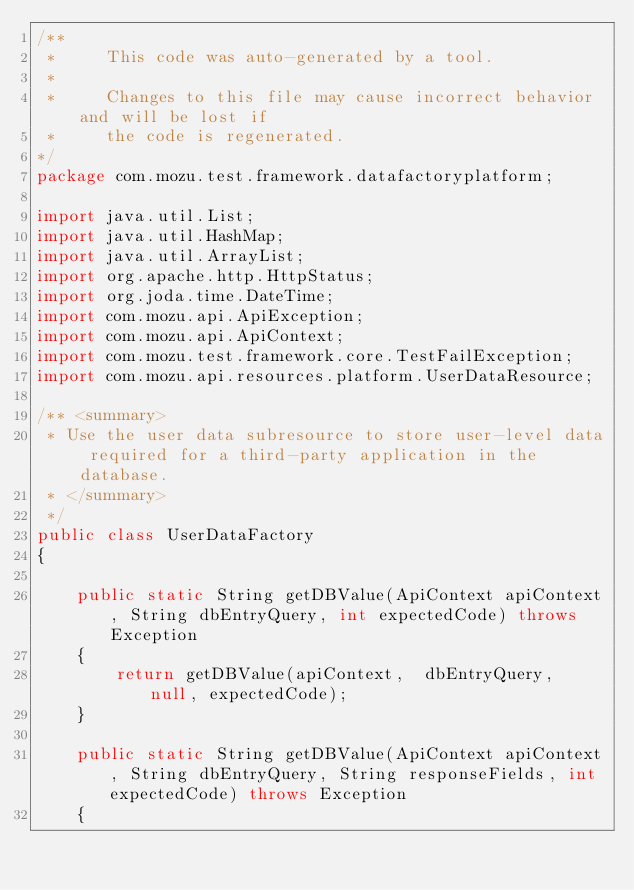<code> <loc_0><loc_0><loc_500><loc_500><_Java_>/**
 *     This code was auto-generated by a tool.     
 *
 *     Changes to this file may cause incorrect behavior and will be lost if
 *     the code is regenerated.
*/
package com.mozu.test.framework.datafactoryplatform;

import java.util.List;
import java.util.HashMap;
import java.util.ArrayList;
import org.apache.http.HttpStatus;
import org.joda.time.DateTime;
import com.mozu.api.ApiException;
import com.mozu.api.ApiContext;
import com.mozu.test.framework.core.TestFailException;
import com.mozu.api.resources.platform.UserDataResource;

/** <summary>
 * Use the user data subresource to store user-level data required for a third-party application in the  database.
 * </summary>
 */
public class UserDataFactory
{

	public static String getDBValue(ApiContext apiContext, String dbEntryQuery, int expectedCode) throws Exception
	{
		return getDBValue(apiContext,  dbEntryQuery,  null, expectedCode);
	}

	public static String getDBValue(ApiContext apiContext, String dbEntryQuery, String responseFields, int expectedCode) throws Exception
	{</code> 